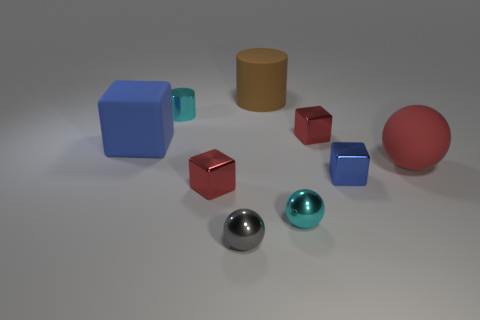Does the brown rubber thing have the same shape as the small gray shiny thing?
Ensure brevity in your answer.  No. How big is the brown cylinder?
Provide a short and direct response. Large. Is the number of cyan things in front of the tiny cyan cylinder greater than the number of cyan things on the left side of the big blue block?
Your answer should be very brief. Yes. There is a red rubber thing; are there any cyan objects in front of it?
Your response must be concise. Yes. Are there any gray cylinders that have the same size as the gray metallic sphere?
Provide a short and direct response. No. There is a large cylinder that is the same material as the red ball; what color is it?
Keep it short and to the point. Brown. What is the large brown cylinder made of?
Give a very brief answer. Rubber. What is the shape of the large red matte thing?
Your response must be concise. Sphere. What number of rubber objects have the same color as the shiny cylinder?
Give a very brief answer. 0. There is a cyan object to the left of the tiny red thing that is left of the small red block that is behind the large blue rubber thing; what is its material?
Provide a short and direct response. Metal. 